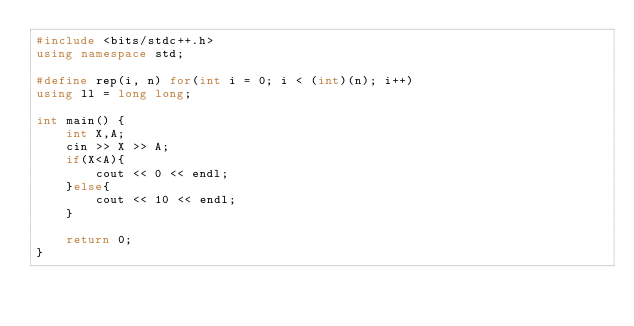<code> <loc_0><loc_0><loc_500><loc_500><_C++_>#include <bits/stdc++.h>
using namespace std;

#define rep(i, n) for(int i = 0; i < (int)(n); i++)
using ll = long long;

int main() {
    int X,A;
    cin >> X >> A;
    if(X<A){
        cout << 0 << endl;
    }else{
        cout << 10 << endl;
    }

    return 0;
}
</code> 